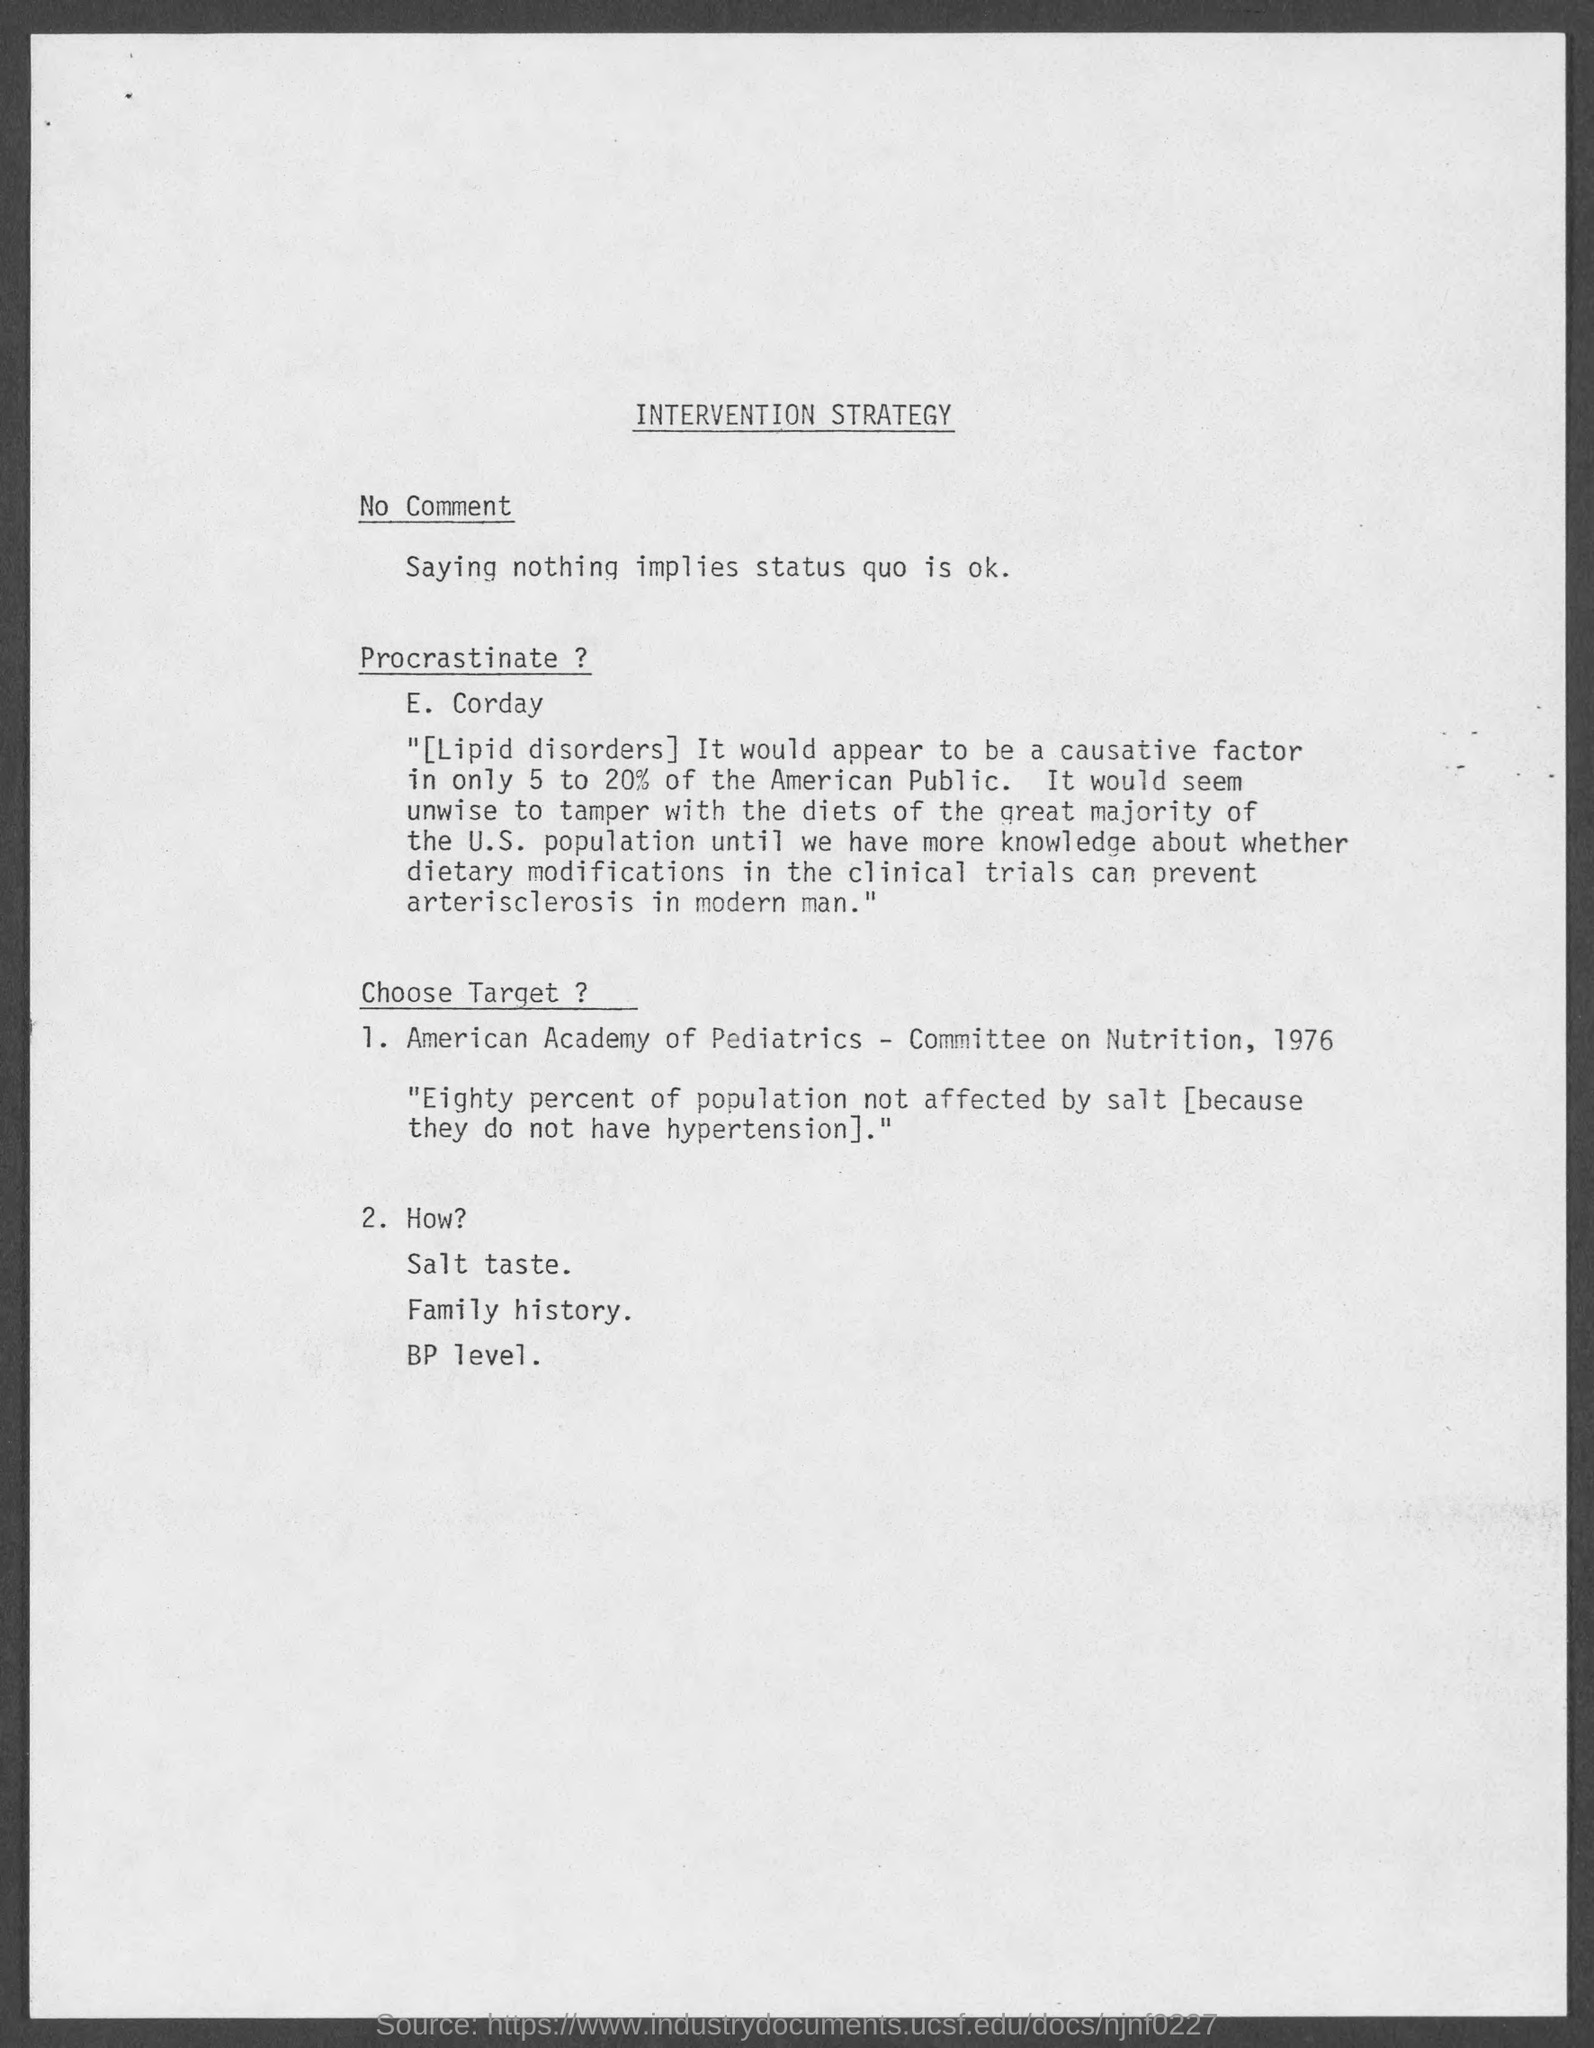Point out several critical features in this image. The heading at the top of the page is 'Intervention Strategy', which declares its purpose as a guide for effective and efficient intervention in various situations. 